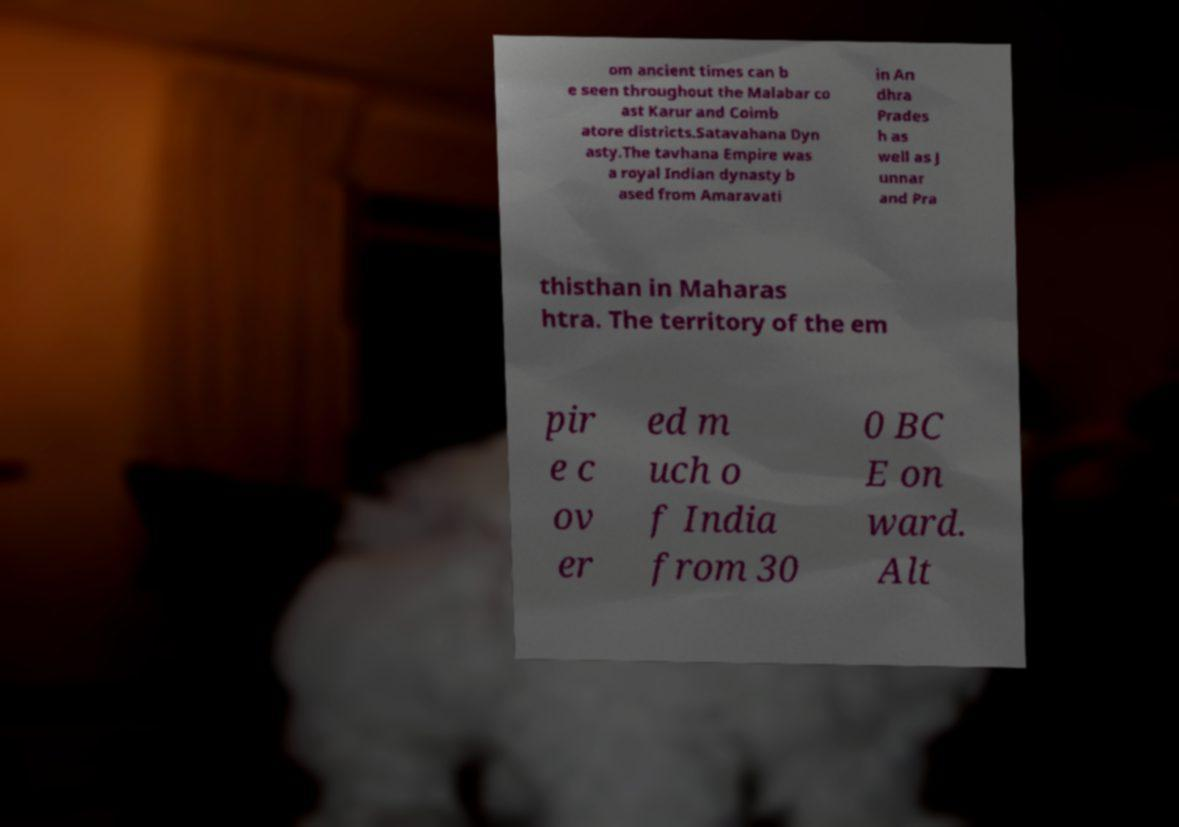Could you assist in decoding the text presented in this image and type it out clearly? om ancient times can b e seen throughout the Malabar co ast Karur and Coimb atore districts.Satavahana Dyn asty.The tavhana Empire was a royal Indian dynasty b ased from Amaravati in An dhra Prades h as well as J unnar and Pra thisthan in Maharas htra. The territory of the em pir e c ov er ed m uch o f India from 30 0 BC E on ward. Alt 